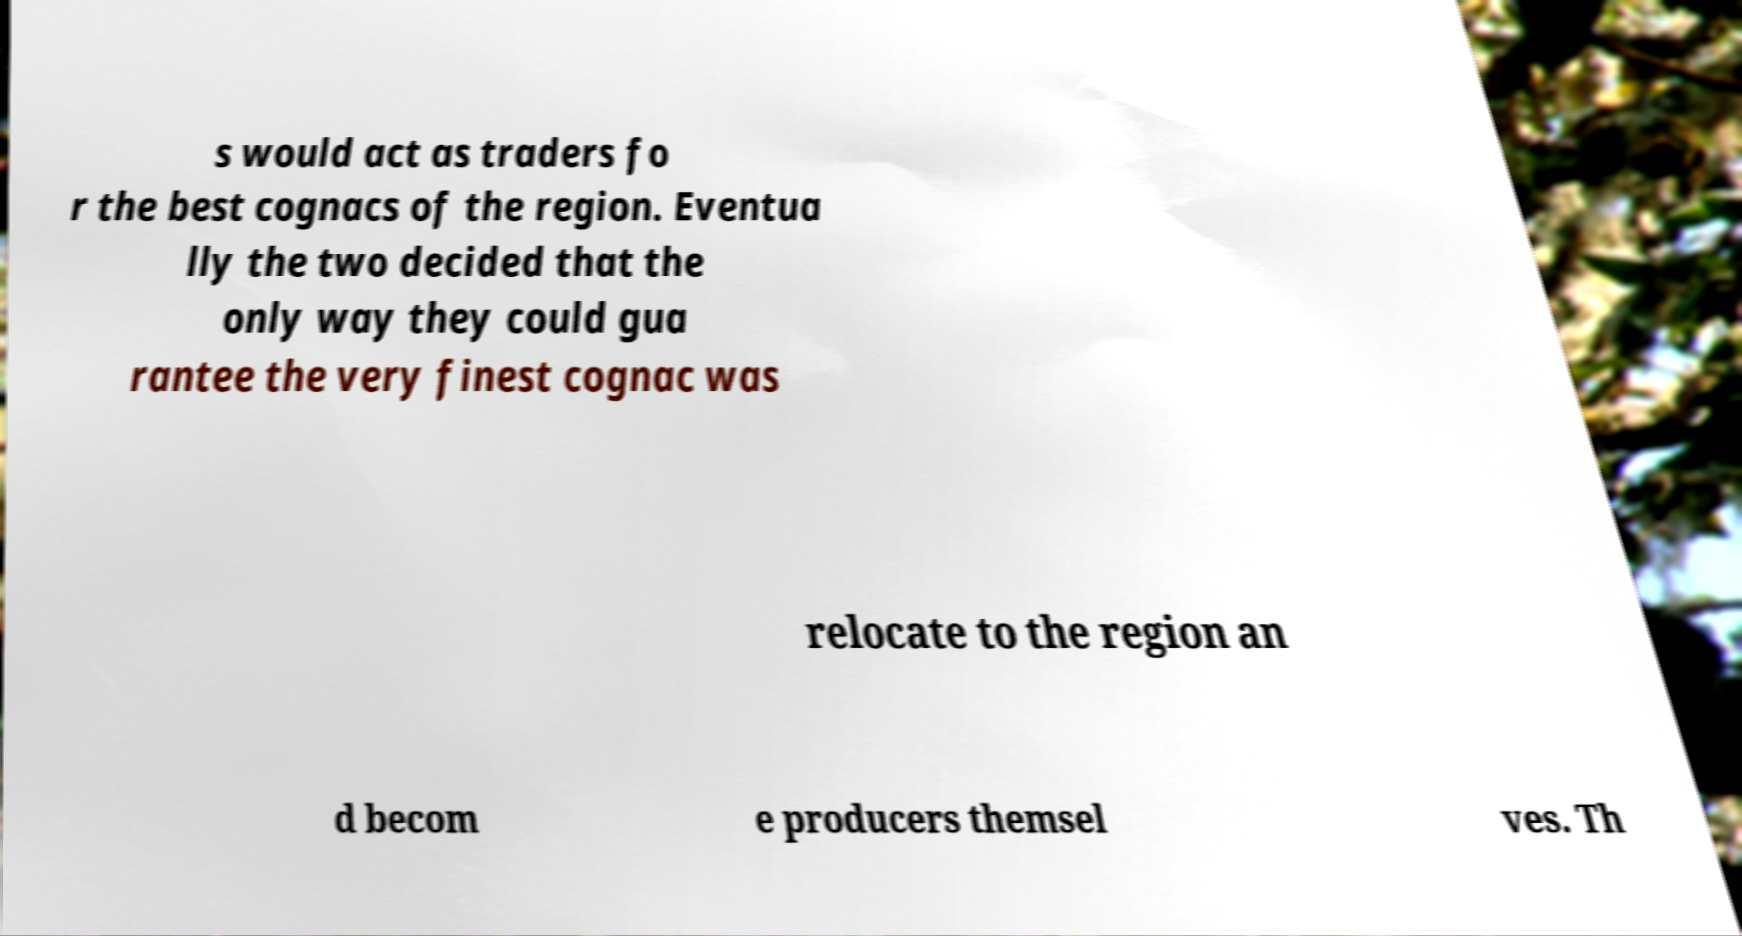What messages or text are displayed in this image? I need them in a readable, typed format. s would act as traders fo r the best cognacs of the region. Eventua lly the two decided that the only way they could gua rantee the very finest cognac was relocate to the region an d becom e producers themsel ves. Th 